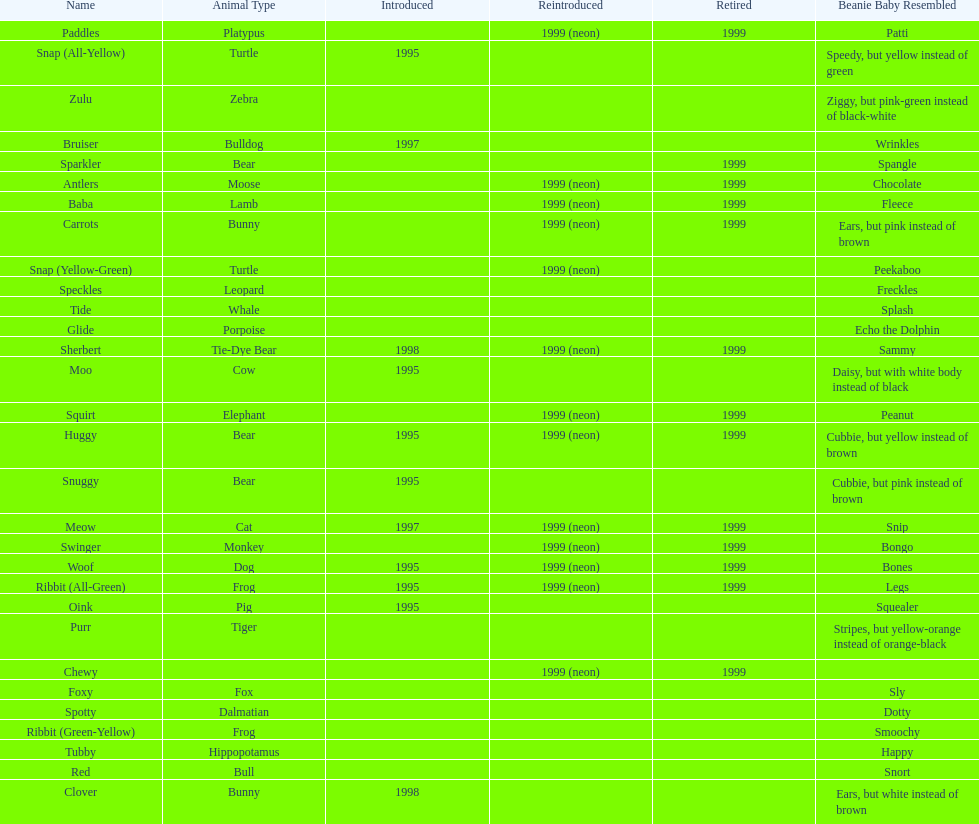Name the only pillow pal that is a dalmatian. Spotty. Can you parse all the data within this table? {'header': ['Name', 'Animal Type', 'Introduced', 'Reintroduced', 'Retired', 'Beanie Baby Resembled'], 'rows': [['Paddles', 'Platypus', '', '1999 (neon)', '1999', 'Patti'], ['Snap (All-Yellow)', 'Turtle', '1995', '', '', 'Speedy, but yellow instead of green'], ['Zulu', 'Zebra', '', '', '', 'Ziggy, but pink-green instead of black-white'], ['Bruiser', 'Bulldog', '1997', '', '', 'Wrinkles'], ['Sparkler', 'Bear', '', '', '1999', 'Spangle'], ['Antlers', 'Moose', '', '1999 (neon)', '1999', 'Chocolate'], ['Baba', 'Lamb', '', '1999 (neon)', '1999', 'Fleece'], ['Carrots', 'Bunny', '', '1999 (neon)', '1999', 'Ears, but pink instead of brown'], ['Snap (Yellow-Green)', 'Turtle', '', '1999 (neon)', '', 'Peekaboo'], ['Speckles', 'Leopard', '', '', '', 'Freckles'], ['Tide', 'Whale', '', '', '', 'Splash'], ['Glide', 'Porpoise', '', '', '', 'Echo the Dolphin'], ['Sherbert', 'Tie-Dye Bear', '1998', '1999 (neon)', '1999', 'Sammy'], ['Moo', 'Cow', '1995', '', '', 'Daisy, but with white body instead of black'], ['Squirt', 'Elephant', '', '1999 (neon)', '1999', 'Peanut'], ['Huggy', 'Bear', '1995', '1999 (neon)', '1999', 'Cubbie, but yellow instead of brown'], ['Snuggy', 'Bear', '1995', '', '', 'Cubbie, but pink instead of brown'], ['Meow', 'Cat', '1997', '1999 (neon)', '1999', 'Snip'], ['Swinger', 'Monkey', '', '1999 (neon)', '1999', 'Bongo'], ['Woof', 'Dog', '1995', '1999 (neon)', '1999', 'Bones'], ['Ribbit (All-Green)', 'Frog', '1995', '1999 (neon)', '1999', 'Legs'], ['Oink', 'Pig', '1995', '', '', 'Squealer'], ['Purr', 'Tiger', '', '', '', 'Stripes, but yellow-orange instead of orange-black'], ['Chewy', '', '', '1999 (neon)', '1999', ''], ['Foxy', 'Fox', '', '', '', 'Sly'], ['Spotty', 'Dalmatian', '', '', '', 'Dotty'], ['Ribbit (Green-Yellow)', 'Frog', '', '', '', 'Smoochy'], ['Tubby', 'Hippopotamus', '', '', '', 'Happy'], ['Red', 'Bull', '', '', '', 'Snort'], ['Clover', 'Bunny', '1998', '', '', 'Ears, but white instead of brown']]} 